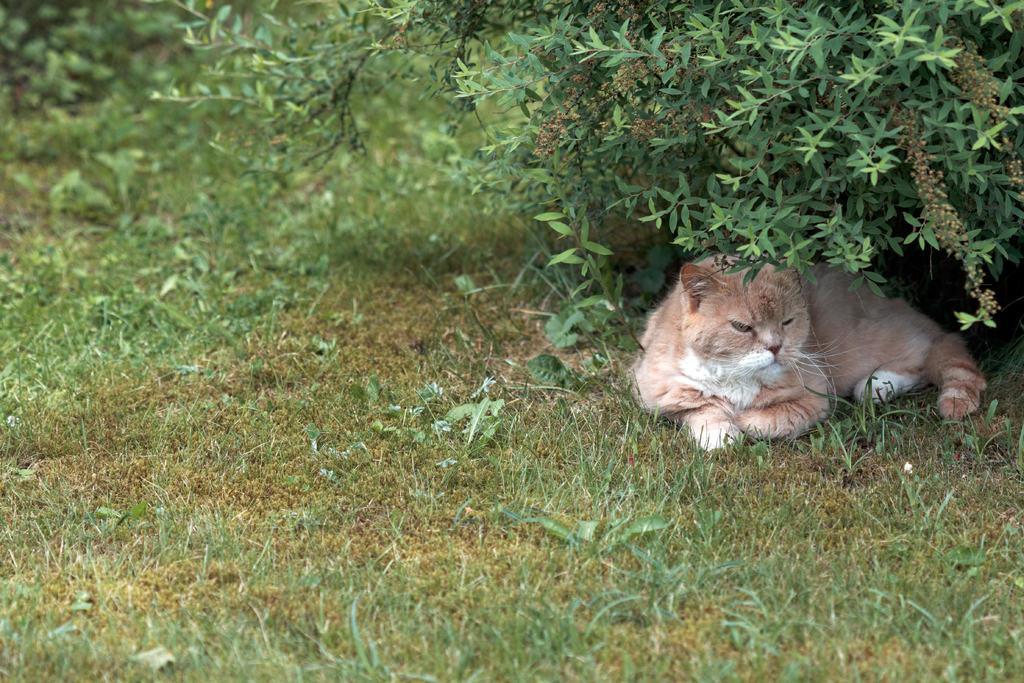Could you give a brief overview of what you see in this image? In this image we can see a cat. In the background of the image there are plants and grass. At the bottom of the image there is the grass. 